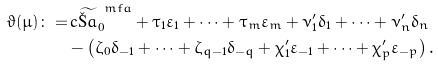<formula> <loc_0><loc_0><loc_500><loc_500>\vartheta ( \mu ) \colon = & \, c \widetilde { \L a } ^ { \ m f a } _ { 0 } + \tau _ { 1 } \varepsilon _ { 1 } + \cdots + \tau _ { m } \varepsilon _ { m } + \nu ^ { \prime } _ { 1 } \delta _ { 1 } + \cdots + \nu ^ { \prime } _ { n } \delta _ { n } \\ & - \left ( \zeta _ { 0 } \delta _ { - 1 } + \cdots + \zeta _ { q - 1 } \delta _ { - q } + \chi ^ { \prime } _ { 1 } \varepsilon _ { - 1 } + \cdots + \chi ^ { \prime } _ { p } \varepsilon _ { - p } \right ) .</formula> 